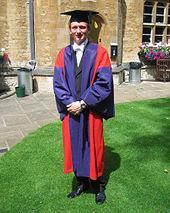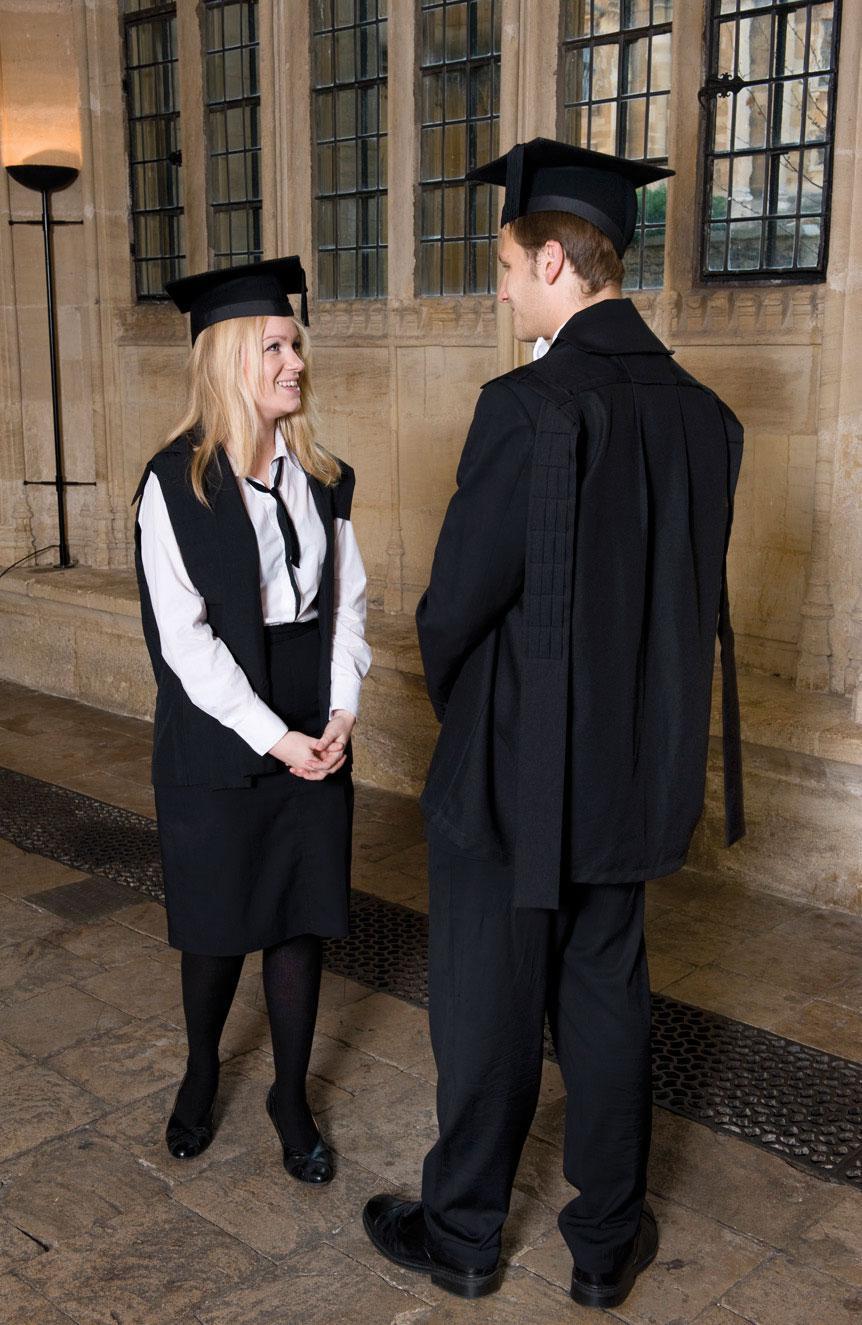The first image is the image on the left, the second image is the image on the right. Examine the images to the left and right. Is the description "An image does not show exactly two people dressed for an occasion." accurate? Answer yes or no. Yes. 